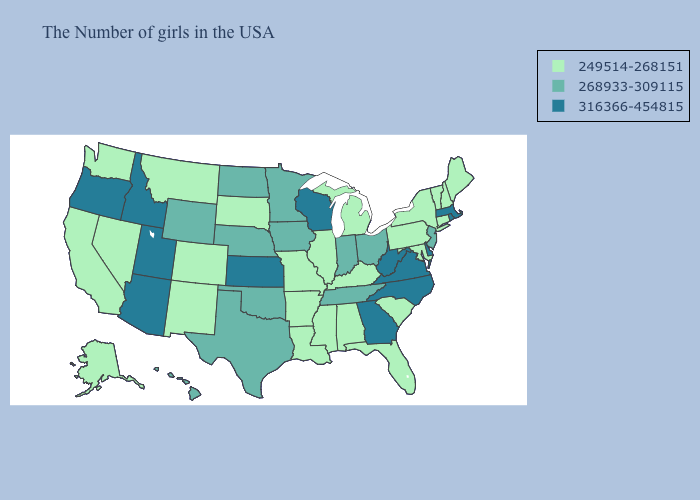Does California have a lower value than Virginia?
Give a very brief answer. Yes. Name the states that have a value in the range 249514-268151?
Quick response, please. Maine, New Hampshire, Vermont, Connecticut, New York, Maryland, Pennsylvania, South Carolina, Florida, Michigan, Kentucky, Alabama, Illinois, Mississippi, Louisiana, Missouri, Arkansas, South Dakota, Colorado, New Mexico, Montana, Nevada, California, Washington, Alaska. What is the lowest value in the South?
Short answer required. 249514-268151. Among the states that border Alabama , which have the lowest value?
Be succinct. Florida, Mississippi. What is the value of Nebraska?
Give a very brief answer. 268933-309115. Does South Dakota have the lowest value in the USA?
Write a very short answer. Yes. What is the value of Alaska?
Answer briefly. 249514-268151. Does North Dakota have the lowest value in the MidWest?
Keep it brief. No. What is the value of Louisiana?
Write a very short answer. 249514-268151. Does Minnesota have a higher value than Wisconsin?
Give a very brief answer. No. Does the first symbol in the legend represent the smallest category?
Short answer required. Yes. Name the states that have a value in the range 249514-268151?
Concise answer only. Maine, New Hampshire, Vermont, Connecticut, New York, Maryland, Pennsylvania, South Carolina, Florida, Michigan, Kentucky, Alabama, Illinois, Mississippi, Louisiana, Missouri, Arkansas, South Dakota, Colorado, New Mexico, Montana, Nevada, California, Washington, Alaska. Which states have the highest value in the USA?
Short answer required. Massachusetts, Rhode Island, Delaware, Virginia, North Carolina, West Virginia, Georgia, Wisconsin, Kansas, Utah, Arizona, Idaho, Oregon. Does Hawaii have the same value as Wyoming?
Give a very brief answer. Yes. 